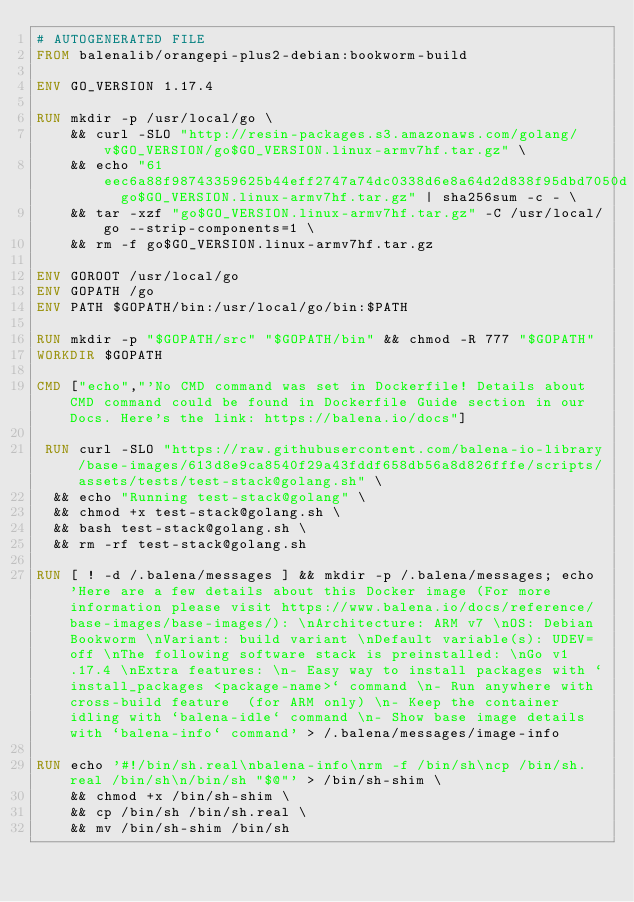Convert code to text. <code><loc_0><loc_0><loc_500><loc_500><_Dockerfile_># AUTOGENERATED FILE
FROM balenalib/orangepi-plus2-debian:bookworm-build

ENV GO_VERSION 1.17.4

RUN mkdir -p /usr/local/go \
	&& curl -SLO "http://resin-packages.s3.amazonaws.com/golang/v$GO_VERSION/go$GO_VERSION.linux-armv7hf.tar.gz" \
	&& echo "61eec6a88f98743359625b44eff2747a74dc0338d6e8a64d2d838f95dbd7050d  go$GO_VERSION.linux-armv7hf.tar.gz" | sha256sum -c - \
	&& tar -xzf "go$GO_VERSION.linux-armv7hf.tar.gz" -C /usr/local/go --strip-components=1 \
	&& rm -f go$GO_VERSION.linux-armv7hf.tar.gz

ENV GOROOT /usr/local/go
ENV GOPATH /go
ENV PATH $GOPATH/bin:/usr/local/go/bin:$PATH

RUN mkdir -p "$GOPATH/src" "$GOPATH/bin" && chmod -R 777 "$GOPATH"
WORKDIR $GOPATH

CMD ["echo","'No CMD command was set in Dockerfile! Details about CMD command could be found in Dockerfile Guide section in our Docs. Here's the link: https://balena.io/docs"]

 RUN curl -SLO "https://raw.githubusercontent.com/balena-io-library/base-images/613d8e9ca8540f29a43fddf658db56a8d826fffe/scripts/assets/tests/test-stack@golang.sh" \
  && echo "Running test-stack@golang" \
  && chmod +x test-stack@golang.sh \
  && bash test-stack@golang.sh \
  && rm -rf test-stack@golang.sh 

RUN [ ! -d /.balena/messages ] && mkdir -p /.balena/messages; echo 'Here are a few details about this Docker image (For more information please visit https://www.balena.io/docs/reference/base-images/base-images/): \nArchitecture: ARM v7 \nOS: Debian Bookworm \nVariant: build variant \nDefault variable(s): UDEV=off \nThe following software stack is preinstalled: \nGo v1.17.4 \nExtra features: \n- Easy way to install packages with `install_packages <package-name>` command \n- Run anywhere with cross-build feature  (for ARM only) \n- Keep the container idling with `balena-idle` command \n- Show base image details with `balena-info` command' > /.balena/messages/image-info

RUN echo '#!/bin/sh.real\nbalena-info\nrm -f /bin/sh\ncp /bin/sh.real /bin/sh\n/bin/sh "$@"' > /bin/sh-shim \
	&& chmod +x /bin/sh-shim \
	&& cp /bin/sh /bin/sh.real \
	&& mv /bin/sh-shim /bin/sh</code> 